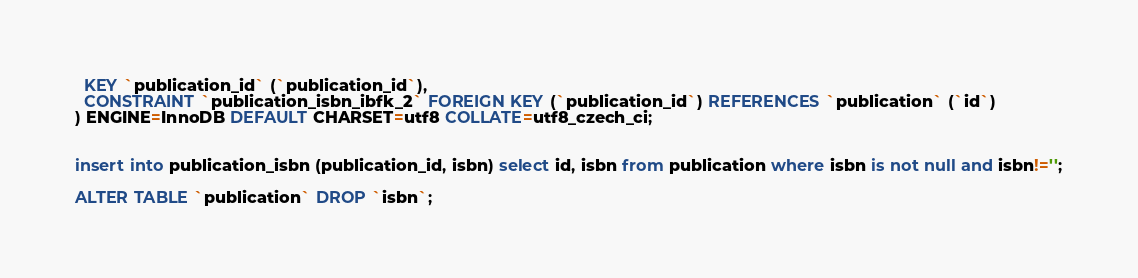<code> <loc_0><loc_0><loc_500><loc_500><_SQL_>  KEY `publication_id` (`publication_id`),
  CONSTRAINT `publication_isbn_ibfk_2` FOREIGN KEY (`publication_id`) REFERENCES `publication` (`id`)
) ENGINE=InnoDB DEFAULT CHARSET=utf8 COLLATE=utf8_czech_ci;


insert into publication_isbn (publication_id, isbn) select id, isbn from publication where isbn is not null and isbn!='';

ALTER TABLE `publication` DROP `isbn`;
</code> 